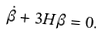Convert formula to latex. <formula><loc_0><loc_0><loc_500><loc_500>\dot { \beta } + 3 H \beta = 0 .</formula> 